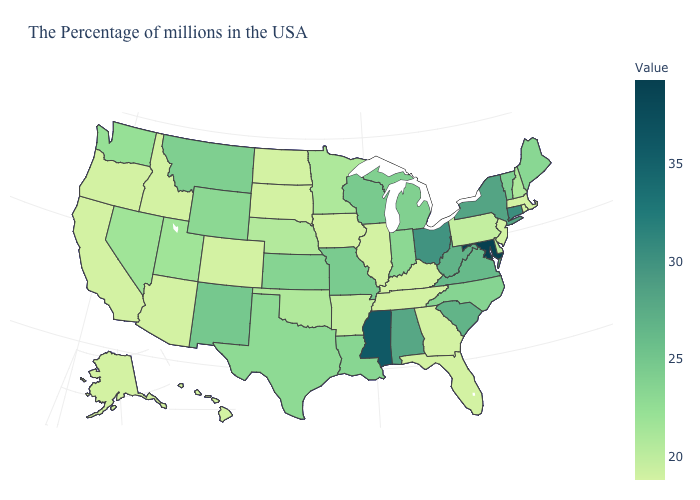Which states have the lowest value in the USA?
Be succinct. Massachusetts, Rhode Island, New Jersey, Florida, Georgia, Kentucky, Tennessee, Illinois, Iowa, South Dakota, North Dakota, Colorado, Arizona, Idaho, California, Oregon, Alaska, Hawaii. Does Kentucky have a higher value than Louisiana?
Write a very short answer. No. Does Maryland have a higher value than California?
Quick response, please. Yes. Which states have the lowest value in the MidWest?
Be succinct. Illinois, Iowa, South Dakota, North Dakota. Does North Carolina have a lower value than New York?
Concise answer only. Yes. 